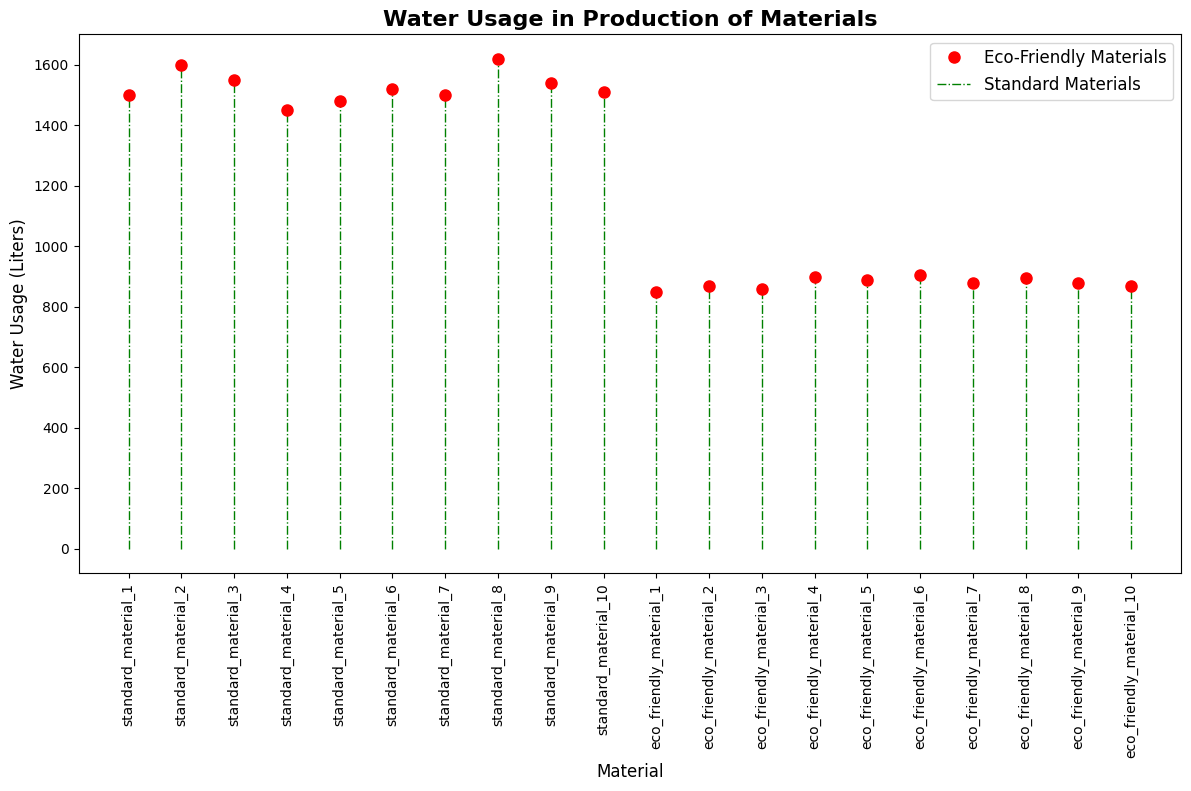What is the material with the highest water usage? To find the material with the highest water usage, locate the point on the plot with the highest vertical position. This corresponds to "standard_material_8" with a water usage of 1620 liters.
Answer: standard_material_8 What is the material with the lowest water usage? To find the material with the lowest water usage, locate the point on the plot with the lowest vertical position. This corresponds to "eco_friendly_material_1" with a water usage of 850 liters.
Answer: eco_friendly_material_1 What is the average water usage of the eco-friendly materials? Locate all the points labeled as eco-friendly materials and sum their water usages: (850 + 870 + 860 + 900 + 890 + 905 + 880 + 895 + 880 + 870). The total is 8700, and there are 10 points, so the average is 8700/10 = 870 liters.
Answer: 870 Which group, eco-friendly or standard materials, has more variability in water usage? Observing the range of water usage values for each group, eco-friendly materials range from 850 to 905 liters, while standard materials range from 1450 to 1620 liters. There is greater variability in standard materials.
Answer: standard materials How many materials have a water usage greater than 900 liters? Count the number of points above the 900 liters mark on the plot. There are eight points in total (all standard materials).
Answer: 8 What is the difference in water usage between the highest and lowest eco-friendly materials? Identify the highest and lowest water usage for eco-friendly materials, which are 905 liters and 850 liters, respectively. The difference is 905 - 850 = 55 liters.
Answer: 55 Which type of material generally uses less water? Compare the general vertical positions of the eco-friendly and standard materials. Eco-friendly materials are positioned significantly lower than standard materials, indicating lower water usage.
Answer: eco-friendly materials What is the median water usage of standard materials? To find the median, first arrange the water usages of standard materials: (1450, 1480, 1500, 1500, 1510, 1520, 1540, 1550, 1600, 1620). The median value is the average of the 5th and 6th values: (1510 + 1520) / 2 = 1515 liters.
Answer: 1515 How much more water does the material with the highest usage consume compared to the one with the lowest usage? The highest water usage is 1620 liters, and the lowest is 850 liters. The difference is 1620 - 850 = 770 liters.
Answer: 770 